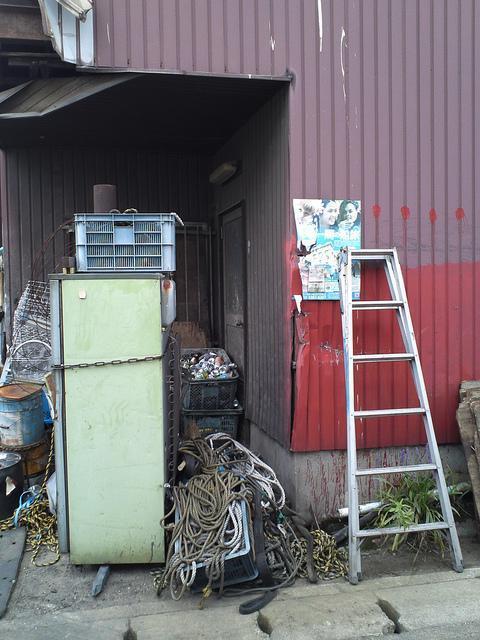How many pots are there?
Give a very brief answer. 0. 